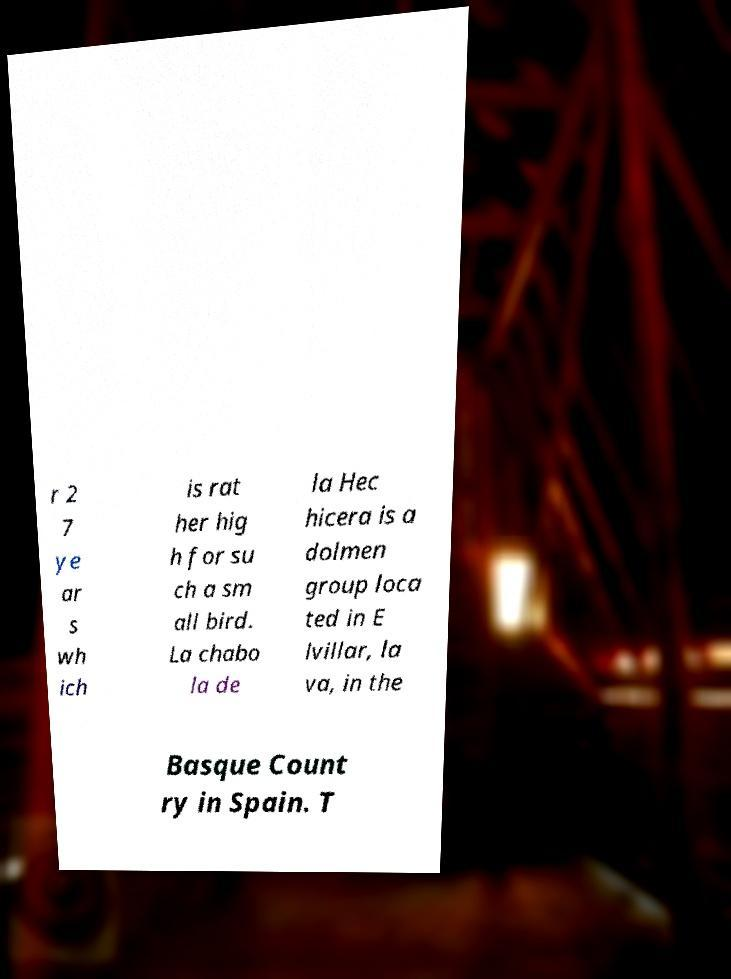I need the written content from this picture converted into text. Can you do that? r 2 7 ye ar s wh ich is rat her hig h for su ch a sm all bird. La chabo la de la Hec hicera is a dolmen group loca ted in E lvillar, la va, in the Basque Count ry in Spain. T 